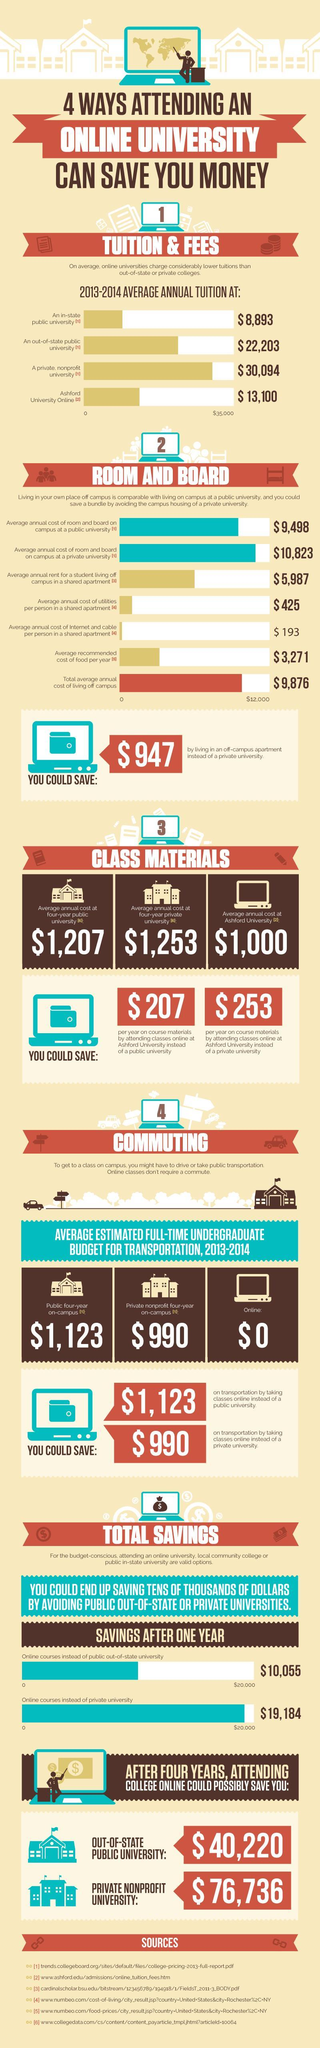What is the average annual cost at four-year public university?
Answer the question with a short phrase. $1,207 What is the average annual cost  for attending online classes at Ashford University? $1,000 